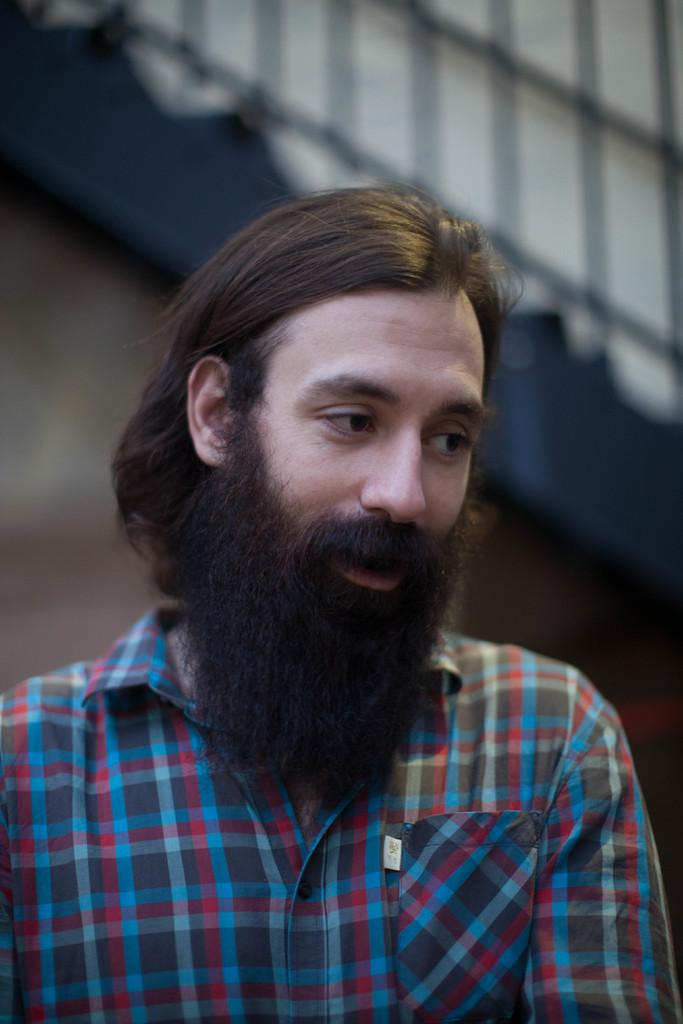Where was the image taken? The image is taken outdoors. What can be seen in the background of the image? There are stairs without railing in the background. Who is the main subject in the image? There is a man in the middle of the image. What facial hair does the man have? The man has a beard and a mustache. Can you see a mountain in the background of the image? No, there is no mountain visible in the background of the image. What type of collar does the man have on his shirt? The man is not wearing a shirt in the image, so there is no collar to describe. 